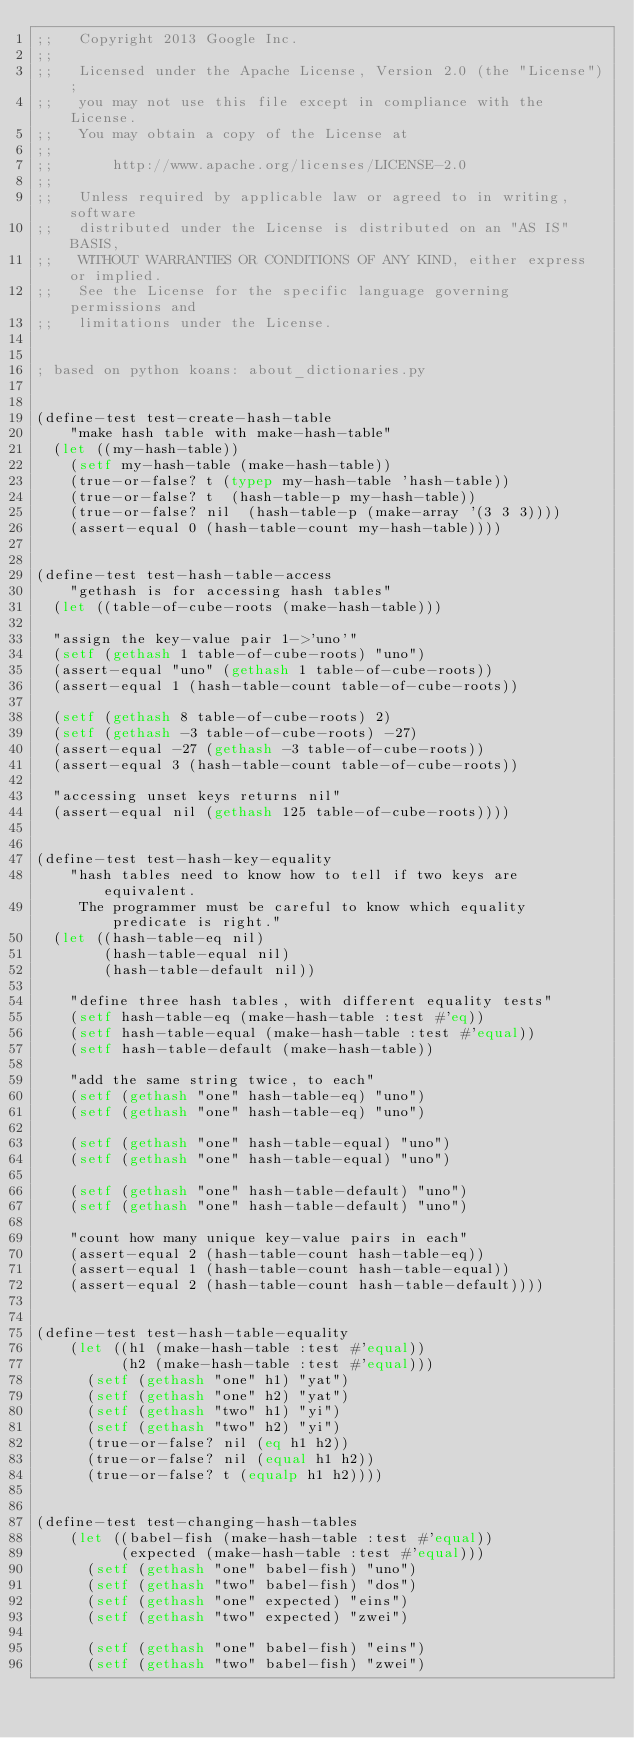<code> <loc_0><loc_0><loc_500><loc_500><_Lisp_>;;   Copyright 2013 Google Inc.
;;
;;   Licensed under the Apache License, Version 2.0 (the "License");
;;   you may not use this file except in compliance with the License.
;;   You may obtain a copy of the License at
;;
;;       http://www.apache.org/licenses/LICENSE-2.0
;;
;;   Unless required by applicable law or agreed to in writing, software
;;   distributed under the License is distributed on an "AS IS" BASIS,
;;   WITHOUT WARRANTIES OR CONDITIONS OF ANY KIND, either express or implied.
;;   See the License for the specific language governing permissions and
;;   limitations under the License.


; based on python koans: about_dictionaries.py


(define-test test-create-hash-table
    "make hash table with make-hash-table"
  (let ((my-hash-table))
    (setf my-hash-table (make-hash-table))
    (true-or-false? t (typep my-hash-table 'hash-table))
    (true-or-false? t  (hash-table-p my-hash-table))
    (true-or-false? nil  (hash-table-p (make-array '(3 3 3))))
    (assert-equal 0 (hash-table-count my-hash-table))))


(define-test test-hash-table-access
    "gethash is for accessing hash tables"
  (let ((table-of-cube-roots (make-hash-table)))

  "assign the key-value pair 1->'uno'"
  (setf (gethash 1 table-of-cube-roots) "uno")
  (assert-equal "uno" (gethash 1 table-of-cube-roots))
  (assert-equal 1 (hash-table-count table-of-cube-roots))

  (setf (gethash 8 table-of-cube-roots) 2)
  (setf (gethash -3 table-of-cube-roots) -27)
  (assert-equal -27 (gethash -3 table-of-cube-roots))
  (assert-equal 3 (hash-table-count table-of-cube-roots))

  "accessing unset keys returns nil"
  (assert-equal nil (gethash 125 table-of-cube-roots))))


(define-test test-hash-key-equality
    "hash tables need to know how to tell if two keys are equivalent.
     The programmer must be careful to know which equality predicate is right."
  (let ((hash-table-eq nil)
        (hash-table-equal nil)
        (hash-table-default nil))

    "define three hash tables, with different equality tests"
    (setf hash-table-eq (make-hash-table :test #'eq))
    (setf hash-table-equal (make-hash-table :test #'equal))
    (setf hash-table-default (make-hash-table))

    "add the same string twice, to each"
    (setf (gethash "one" hash-table-eq) "uno")
    (setf (gethash "one" hash-table-eq) "uno")

    (setf (gethash "one" hash-table-equal) "uno")
    (setf (gethash "one" hash-table-equal) "uno")

    (setf (gethash "one" hash-table-default) "uno")
    (setf (gethash "one" hash-table-default) "uno")

    "count how many unique key-value pairs in each"
    (assert-equal 2 (hash-table-count hash-table-eq))
    (assert-equal 1 (hash-table-count hash-table-equal))
    (assert-equal 2 (hash-table-count hash-table-default))))


(define-test test-hash-table-equality
    (let ((h1 (make-hash-table :test #'equal))
          (h2 (make-hash-table :test #'equal)))
      (setf (gethash "one" h1) "yat")
      (setf (gethash "one" h2) "yat")
      (setf (gethash "two" h1) "yi")
      (setf (gethash "two" h2) "yi")
      (true-or-false? nil (eq h1 h2))
      (true-or-false? nil (equal h1 h2))
      (true-or-false? t (equalp h1 h2))))


(define-test test-changing-hash-tables
    (let ((babel-fish (make-hash-table :test #'equal))
          (expected (make-hash-table :test #'equal)))
      (setf (gethash "one" babel-fish) "uno")
      (setf (gethash "two" babel-fish) "dos")
      (setf (gethash "one" expected) "eins")
      (setf (gethash "two" expected) "zwei")

      (setf (gethash "one" babel-fish) "eins")
      (setf (gethash "two" babel-fish) "zwei")
</code> 